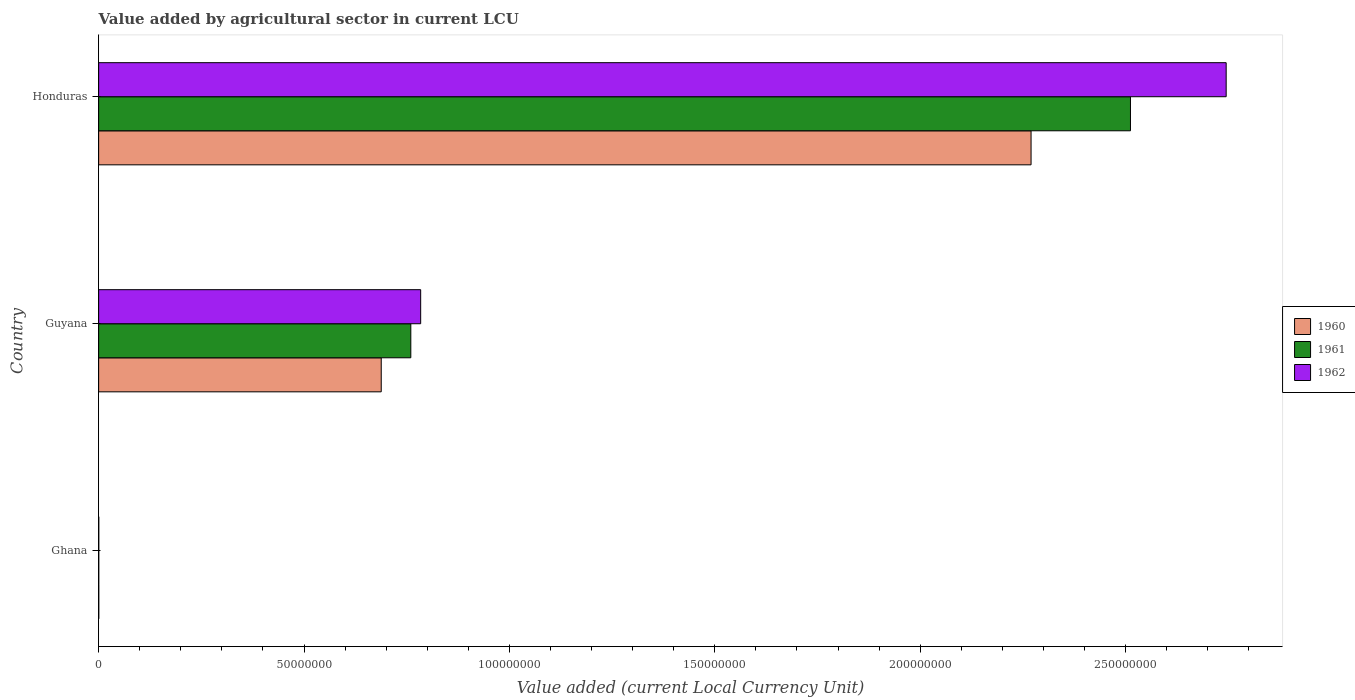How many groups of bars are there?
Provide a short and direct response. 3. Are the number of bars on each tick of the Y-axis equal?
Your answer should be compact. Yes. How many bars are there on the 1st tick from the top?
Provide a succinct answer. 3. What is the value added by agricultural sector in 1960 in Ghana?
Keep it short and to the point. 3.55e+04. Across all countries, what is the maximum value added by agricultural sector in 1962?
Make the answer very short. 2.74e+08. Across all countries, what is the minimum value added by agricultural sector in 1960?
Make the answer very short. 3.55e+04. In which country was the value added by agricultural sector in 1960 maximum?
Provide a short and direct response. Honduras. In which country was the value added by agricultural sector in 1962 minimum?
Make the answer very short. Ghana. What is the total value added by agricultural sector in 1961 in the graph?
Your answer should be very brief. 3.27e+08. What is the difference between the value added by agricultural sector in 1962 in Ghana and that in Guyana?
Keep it short and to the point. -7.84e+07. What is the difference between the value added by agricultural sector in 1961 in Guyana and the value added by agricultural sector in 1962 in Honduras?
Ensure brevity in your answer.  -1.98e+08. What is the average value added by agricultural sector in 1961 per country?
Ensure brevity in your answer.  1.09e+08. What is the difference between the value added by agricultural sector in 1962 and value added by agricultural sector in 1960 in Honduras?
Your response must be concise. 4.75e+07. In how many countries, is the value added by agricultural sector in 1962 greater than 220000000 LCU?
Keep it short and to the point. 1. What is the ratio of the value added by agricultural sector in 1960 in Guyana to that in Honduras?
Make the answer very short. 0.3. Is the value added by agricultural sector in 1960 in Guyana less than that in Honduras?
Keep it short and to the point. Yes. What is the difference between the highest and the second highest value added by agricultural sector in 1960?
Ensure brevity in your answer.  1.58e+08. What is the difference between the highest and the lowest value added by agricultural sector in 1961?
Provide a short and direct response. 2.51e+08. Is the sum of the value added by agricultural sector in 1962 in Guyana and Honduras greater than the maximum value added by agricultural sector in 1961 across all countries?
Your response must be concise. Yes. Are all the bars in the graph horizontal?
Provide a short and direct response. Yes. How many countries are there in the graph?
Keep it short and to the point. 3. What is the difference between two consecutive major ticks on the X-axis?
Your answer should be compact. 5.00e+07. Where does the legend appear in the graph?
Your response must be concise. Center right. How many legend labels are there?
Provide a short and direct response. 3. How are the legend labels stacked?
Give a very brief answer. Vertical. What is the title of the graph?
Your answer should be very brief. Value added by agricultural sector in current LCU. Does "1990" appear as one of the legend labels in the graph?
Make the answer very short. No. What is the label or title of the X-axis?
Provide a succinct answer. Value added (current Local Currency Unit). What is the Value added (current Local Currency Unit) of 1960 in Ghana?
Offer a very short reply. 3.55e+04. What is the Value added (current Local Currency Unit) in 1961 in Ghana?
Give a very brief answer. 3.29e+04. What is the Value added (current Local Currency Unit) in 1962 in Ghana?
Provide a short and direct response. 3.74e+04. What is the Value added (current Local Currency Unit) of 1960 in Guyana?
Make the answer very short. 6.88e+07. What is the Value added (current Local Currency Unit) in 1961 in Guyana?
Provide a succinct answer. 7.60e+07. What is the Value added (current Local Currency Unit) in 1962 in Guyana?
Offer a terse response. 7.84e+07. What is the Value added (current Local Currency Unit) in 1960 in Honduras?
Keep it short and to the point. 2.27e+08. What is the Value added (current Local Currency Unit) in 1961 in Honduras?
Make the answer very short. 2.51e+08. What is the Value added (current Local Currency Unit) in 1962 in Honduras?
Offer a very short reply. 2.74e+08. Across all countries, what is the maximum Value added (current Local Currency Unit) of 1960?
Offer a very short reply. 2.27e+08. Across all countries, what is the maximum Value added (current Local Currency Unit) in 1961?
Your answer should be compact. 2.51e+08. Across all countries, what is the maximum Value added (current Local Currency Unit) of 1962?
Provide a short and direct response. 2.74e+08. Across all countries, what is the minimum Value added (current Local Currency Unit) in 1960?
Offer a terse response. 3.55e+04. Across all countries, what is the minimum Value added (current Local Currency Unit) of 1961?
Provide a short and direct response. 3.29e+04. Across all countries, what is the minimum Value added (current Local Currency Unit) in 1962?
Offer a very short reply. 3.74e+04. What is the total Value added (current Local Currency Unit) in 1960 in the graph?
Keep it short and to the point. 2.96e+08. What is the total Value added (current Local Currency Unit) in 1961 in the graph?
Ensure brevity in your answer.  3.27e+08. What is the total Value added (current Local Currency Unit) in 1962 in the graph?
Ensure brevity in your answer.  3.53e+08. What is the difference between the Value added (current Local Currency Unit) of 1960 in Ghana and that in Guyana?
Offer a very short reply. -6.88e+07. What is the difference between the Value added (current Local Currency Unit) in 1961 in Ghana and that in Guyana?
Your response must be concise. -7.60e+07. What is the difference between the Value added (current Local Currency Unit) of 1962 in Ghana and that in Guyana?
Ensure brevity in your answer.  -7.84e+07. What is the difference between the Value added (current Local Currency Unit) in 1960 in Ghana and that in Honduras?
Your answer should be compact. -2.27e+08. What is the difference between the Value added (current Local Currency Unit) in 1961 in Ghana and that in Honduras?
Offer a very short reply. -2.51e+08. What is the difference between the Value added (current Local Currency Unit) of 1962 in Ghana and that in Honduras?
Your answer should be compact. -2.74e+08. What is the difference between the Value added (current Local Currency Unit) of 1960 in Guyana and that in Honduras?
Provide a short and direct response. -1.58e+08. What is the difference between the Value added (current Local Currency Unit) in 1961 in Guyana and that in Honduras?
Provide a short and direct response. -1.75e+08. What is the difference between the Value added (current Local Currency Unit) of 1962 in Guyana and that in Honduras?
Provide a succinct answer. -1.96e+08. What is the difference between the Value added (current Local Currency Unit) in 1960 in Ghana and the Value added (current Local Currency Unit) in 1961 in Guyana?
Offer a terse response. -7.60e+07. What is the difference between the Value added (current Local Currency Unit) in 1960 in Ghana and the Value added (current Local Currency Unit) in 1962 in Guyana?
Your response must be concise. -7.84e+07. What is the difference between the Value added (current Local Currency Unit) in 1961 in Ghana and the Value added (current Local Currency Unit) in 1962 in Guyana?
Keep it short and to the point. -7.84e+07. What is the difference between the Value added (current Local Currency Unit) in 1960 in Ghana and the Value added (current Local Currency Unit) in 1961 in Honduras?
Keep it short and to the point. -2.51e+08. What is the difference between the Value added (current Local Currency Unit) of 1960 in Ghana and the Value added (current Local Currency Unit) of 1962 in Honduras?
Give a very brief answer. -2.74e+08. What is the difference between the Value added (current Local Currency Unit) of 1961 in Ghana and the Value added (current Local Currency Unit) of 1962 in Honduras?
Keep it short and to the point. -2.74e+08. What is the difference between the Value added (current Local Currency Unit) of 1960 in Guyana and the Value added (current Local Currency Unit) of 1961 in Honduras?
Offer a terse response. -1.82e+08. What is the difference between the Value added (current Local Currency Unit) in 1960 in Guyana and the Value added (current Local Currency Unit) in 1962 in Honduras?
Offer a very short reply. -2.06e+08. What is the difference between the Value added (current Local Currency Unit) in 1961 in Guyana and the Value added (current Local Currency Unit) in 1962 in Honduras?
Give a very brief answer. -1.98e+08. What is the average Value added (current Local Currency Unit) in 1960 per country?
Provide a short and direct response. 9.86e+07. What is the average Value added (current Local Currency Unit) of 1961 per country?
Give a very brief answer. 1.09e+08. What is the average Value added (current Local Currency Unit) in 1962 per country?
Keep it short and to the point. 1.18e+08. What is the difference between the Value added (current Local Currency Unit) of 1960 and Value added (current Local Currency Unit) of 1961 in Ghana?
Give a very brief answer. 2600. What is the difference between the Value added (current Local Currency Unit) in 1960 and Value added (current Local Currency Unit) in 1962 in Ghana?
Ensure brevity in your answer.  -1900. What is the difference between the Value added (current Local Currency Unit) of 1961 and Value added (current Local Currency Unit) of 1962 in Ghana?
Make the answer very short. -4500. What is the difference between the Value added (current Local Currency Unit) in 1960 and Value added (current Local Currency Unit) in 1961 in Guyana?
Provide a short and direct response. -7.20e+06. What is the difference between the Value added (current Local Currency Unit) in 1960 and Value added (current Local Currency Unit) in 1962 in Guyana?
Make the answer very short. -9.60e+06. What is the difference between the Value added (current Local Currency Unit) of 1961 and Value added (current Local Currency Unit) of 1962 in Guyana?
Make the answer very short. -2.40e+06. What is the difference between the Value added (current Local Currency Unit) of 1960 and Value added (current Local Currency Unit) of 1961 in Honduras?
Provide a short and direct response. -2.42e+07. What is the difference between the Value added (current Local Currency Unit) of 1960 and Value added (current Local Currency Unit) of 1962 in Honduras?
Keep it short and to the point. -4.75e+07. What is the difference between the Value added (current Local Currency Unit) of 1961 and Value added (current Local Currency Unit) of 1962 in Honduras?
Ensure brevity in your answer.  -2.33e+07. What is the ratio of the Value added (current Local Currency Unit) in 1960 in Ghana to that in Guyana?
Make the answer very short. 0. What is the ratio of the Value added (current Local Currency Unit) in 1962 in Ghana to that in Guyana?
Give a very brief answer. 0. What is the ratio of the Value added (current Local Currency Unit) of 1961 in Ghana to that in Honduras?
Your answer should be very brief. 0. What is the ratio of the Value added (current Local Currency Unit) in 1962 in Ghana to that in Honduras?
Provide a short and direct response. 0. What is the ratio of the Value added (current Local Currency Unit) in 1960 in Guyana to that in Honduras?
Your answer should be compact. 0.3. What is the ratio of the Value added (current Local Currency Unit) of 1961 in Guyana to that in Honduras?
Make the answer very short. 0.3. What is the ratio of the Value added (current Local Currency Unit) of 1962 in Guyana to that in Honduras?
Offer a terse response. 0.29. What is the difference between the highest and the second highest Value added (current Local Currency Unit) in 1960?
Give a very brief answer. 1.58e+08. What is the difference between the highest and the second highest Value added (current Local Currency Unit) in 1961?
Offer a very short reply. 1.75e+08. What is the difference between the highest and the second highest Value added (current Local Currency Unit) in 1962?
Provide a succinct answer. 1.96e+08. What is the difference between the highest and the lowest Value added (current Local Currency Unit) of 1960?
Offer a very short reply. 2.27e+08. What is the difference between the highest and the lowest Value added (current Local Currency Unit) of 1961?
Give a very brief answer. 2.51e+08. What is the difference between the highest and the lowest Value added (current Local Currency Unit) in 1962?
Offer a very short reply. 2.74e+08. 